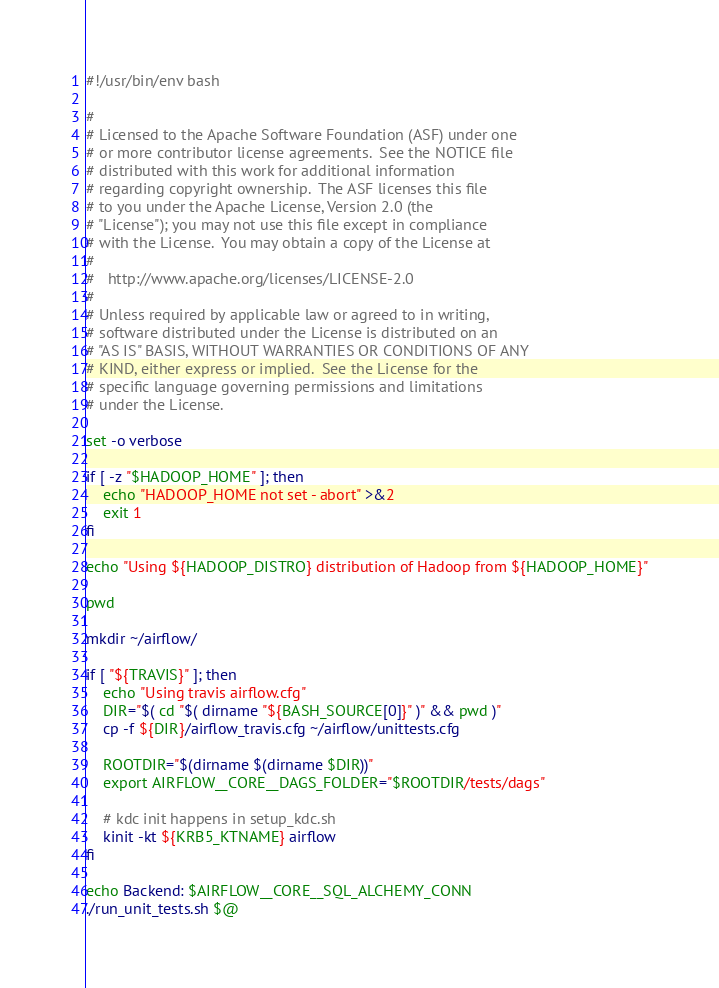Convert code to text. <code><loc_0><loc_0><loc_500><loc_500><_Bash_>#!/usr/bin/env bash

#
# Licensed to the Apache Software Foundation (ASF) under one
# or more contributor license agreements.  See the NOTICE file
# distributed with this work for additional information
# regarding copyright ownership.  The ASF licenses this file
# to you under the Apache License, Version 2.0 (the
# "License"); you may not use this file except in compliance
# with the License.  You may obtain a copy of the License at
# 
#   http://www.apache.org/licenses/LICENSE-2.0
# 
# Unless required by applicable law or agreed to in writing,
# software distributed under the License is distributed on an
# "AS IS" BASIS, WITHOUT WARRANTIES OR CONDITIONS OF ANY
# KIND, either express or implied.  See the License for the
# specific language governing permissions and limitations
# under the License.

set -o verbose

if [ -z "$HADOOP_HOME" ]; then
    echo "HADOOP_HOME not set - abort" >&2
    exit 1
fi

echo "Using ${HADOOP_DISTRO} distribution of Hadoop from ${HADOOP_HOME}"

pwd

mkdir ~/airflow/

if [ "${TRAVIS}" ]; then
    echo "Using travis airflow.cfg"
    DIR="$( cd "$( dirname "${BASH_SOURCE[0]}" )" && pwd )"
    cp -f ${DIR}/airflow_travis.cfg ~/airflow/unittests.cfg

    ROOTDIR="$(dirname $(dirname $DIR))"
    export AIRFLOW__CORE__DAGS_FOLDER="$ROOTDIR/tests/dags"

    # kdc init happens in setup_kdc.sh
    kinit -kt ${KRB5_KTNAME} airflow
fi

echo Backend: $AIRFLOW__CORE__SQL_ALCHEMY_CONN
./run_unit_tests.sh $@
</code> 